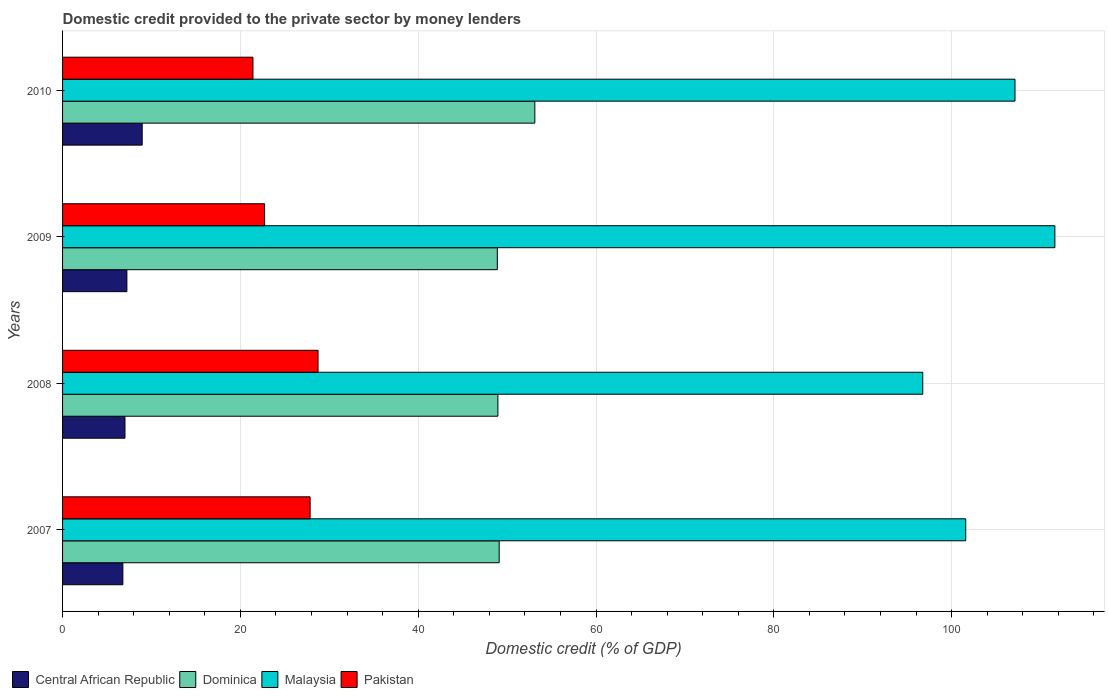How many different coloured bars are there?
Your answer should be very brief. 4. How many groups of bars are there?
Offer a terse response. 4. Are the number of bars per tick equal to the number of legend labels?
Keep it short and to the point. Yes. Are the number of bars on each tick of the Y-axis equal?
Offer a very short reply. Yes. In how many cases, is the number of bars for a given year not equal to the number of legend labels?
Make the answer very short. 0. What is the domestic credit provided to the private sector by money lenders in Pakistan in 2010?
Offer a terse response. 21.41. Across all years, what is the maximum domestic credit provided to the private sector by money lenders in Central African Republic?
Ensure brevity in your answer.  8.96. Across all years, what is the minimum domestic credit provided to the private sector by money lenders in Central African Republic?
Provide a short and direct response. 6.78. In which year was the domestic credit provided to the private sector by money lenders in Central African Republic minimum?
Offer a terse response. 2007. What is the total domestic credit provided to the private sector by money lenders in Malaysia in the graph?
Offer a terse response. 417.06. What is the difference between the domestic credit provided to the private sector by money lenders in Malaysia in 2008 and that in 2010?
Your response must be concise. -10.37. What is the difference between the domestic credit provided to the private sector by money lenders in Malaysia in 2009 and the domestic credit provided to the private sector by money lenders in Central African Republic in 2008?
Offer a very short reply. 104.59. What is the average domestic credit provided to the private sector by money lenders in Central African Republic per year?
Keep it short and to the point. 7.5. In the year 2010, what is the difference between the domestic credit provided to the private sector by money lenders in Malaysia and domestic credit provided to the private sector by money lenders in Pakistan?
Make the answer very short. 85.71. What is the ratio of the domestic credit provided to the private sector by money lenders in Pakistan in 2008 to that in 2010?
Offer a terse response. 1.34. Is the difference between the domestic credit provided to the private sector by money lenders in Malaysia in 2008 and 2010 greater than the difference between the domestic credit provided to the private sector by money lenders in Pakistan in 2008 and 2010?
Provide a succinct answer. No. What is the difference between the highest and the second highest domestic credit provided to the private sector by money lenders in Pakistan?
Your answer should be very brief. 0.89. What is the difference between the highest and the lowest domestic credit provided to the private sector by money lenders in Central African Republic?
Your answer should be very brief. 2.17. In how many years, is the domestic credit provided to the private sector by money lenders in Pakistan greater than the average domestic credit provided to the private sector by money lenders in Pakistan taken over all years?
Your response must be concise. 2. Is the sum of the domestic credit provided to the private sector by money lenders in Dominica in 2007 and 2010 greater than the maximum domestic credit provided to the private sector by money lenders in Central African Republic across all years?
Make the answer very short. Yes. Is it the case that in every year, the sum of the domestic credit provided to the private sector by money lenders in Malaysia and domestic credit provided to the private sector by money lenders in Dominica is greater than the sum of domestic credit provided to the private sector by money lenders in Central African Republic and domestic credit provided to the private sector by money lenders in Pakistan?
Provide a succinct answer. Yes. What does the 1st bar from the bottom in 2008 represents?
Make the answer very short. Central African Republic. How many bars are there?
Offer a terse response. 16. How many years are there in the graph?
Offer a very short reply. 4. What is the difference between two consecutive major ticks on the X-axis?
Ensure brevity in your answer.  20. Are the values on the major ticks of X-axis written in scientific E-notation?
Give a very brief answer. No. Does the graph contain any zero values?
Give a very brief answer. No. Does the graph contain grids?
Give a very brief answer. Yes. Where does the legend appear in the graph?
Your answer should be compact. Bottom left. How many legend labels are there?
Your response must be concise. 4. What is the title of the graph?
Provide a succinct answer. Domestic credit provided to the private sector by money lenders. What is the label or title of the X-axis?
Your response must be concise. Domestic credit (% of GDP). What is the label or title of the Y-axis?
Provide a succinct answer. Years. What is the Domestic credit (% of GDP) of Central African Republic in 2007?
Ensure brevity in your answer.  6.78. What is the Domestic credit (% of GDP) in Dominica in 2007?
Keep it short and to the point. 49.11. What is the Domestic credit (% of GDP) of Malaysia in 2007?
Your answer should be compact. 101.58. What is the Domestic credit (% of GDP) of Pakistan in 2007?
Your answer should be very brief. 27.84. What is the Domestic credit (% of GDP) of Central African Republic in 2008?
Your response must be concise. 7.02. What is the Domestic credit (% of GDP) of Dominica in 2008?
Your answer should be very brief. 48.96. What is the Domestic credit (% of GDP) of Malaysia in 2008?
Make the answer very short. 96.75. What is the Domestic credit (% of GDP) of Pakistan in 2008?
Your response must be concise. 28.73. What is the Domestic credit (% of GDP) of Central African Republic in 2009?
Your answer should be compact. 7.23. What is the Domestic credit (% of GDP) in Dominica in 2009?
Give a very brief answer. 48.9. What is the Domestic credit (% of GDP) of Malaysia in 2009?
Give a very brief answer. 111.61. What is the Domestic credit (% of GDP) of Pakistan in 2009?
Offer a very short reply. 22.72. What is the Domestic credit (% of GDP) of Central African Republic in 2010?
Ensure brevity in your answer.  8.96. What is the Domestic credit (% of GDP) of Dominica in 2010?
Provide a short and direct response. 53.12. What is the Domestic credit (% of GDP) in Malaysia in 2010?
Provide a short and direct response. 107.12. What is the Domestic credit (% of GDP) in Pakistan in 2010?
Offer a terse response. 21.41. Across all years, what is the maximum Domestic credit (% of GDP) in Central African Republic?
Provide a short and direct response. 8.96. Across all years, what is the maximum Domestic credit (% of GDP) in Dominica?
Keep it short and to the point. 53.12. Across all years, what is the maximum Domestic credit (% of GDP) of Malaysia?
Ensure brevity in your answer.  111.61. Across all years, what is the maximum Domestic credit (% of GDP) in Pakistan?
Ensure brevity in your answer.  28.73. Across all years, what is the minimum Domestic credit (% of GDP) of Central African Republic?
Provide a succinct answer. 6.78. Across all years, what is the minimum Domestic credit (% of GDP) in Dominica?
Ensure brevity in your answer.  48.9. Across all years, what is the minimum Domestic credit (% of GDP) of Malaysia?
Make the answer very short. 96.75. Across all years, what is the minimum Domestic credit (% of GDP) in Pakistan?
Ensure brevity in your answer.  21.41. What is the total Domestic credit (% of GDP) of Central African Republic in the graph?
Your answer should be compact. 29.99. What is the total Domestic credit (% of GDP) of Dominica in the graph?
Provide a succinct answer. 200.08. What is the total Domestic credit (% of GDP) of Malaysia in the graph?
Offer a terse response. 417.06. What is the total Domestic credit (% of GDP) in Pakistan in the graph?
Provide a short and direct response. 100.71. What is the difference between the Domestic credit (% of GDP) of Central African Republic in 2007 and that in 2008?
Make the answer very short. -0.24. What is the difference between the Domestic credit (% of GDP) of Dominica in 2007 and that in 2008?
Offer a very short reply. 0.15. What is the difference between the Domestic credit (% of GDP) of Malaysia in 2007 and that in 2008?
Ensure brevity in your answer.  4.83. What is the difference between the Domestic credit (% of GDP) of Pakistan in 2007 and that in 2008?
Give a very brief answer. -0.89. What is the difference between the Domestic credit (% of GDP) of Central African Republic in 2007 and that in 2009?
Provide a succinct answer. -0.45. What is the difference between the Domestic credit (% of GDP) in Dominica in 2007 and that in 2009?
Ensure brevity in your answer.  0.21. What is the difference between the Domestic credit (% of GDP) of Malaysia in 2007 and that in 2009?
Ensure brevity in your answer.  -10.03. What is the difference between the Domestic credit (% of GDP) of Pakistan in 2007 and that in 2009?
Ensure brevity in your answer.  5.12. What is the difference between the Domestic credit (% of GDP) of Central African Republic in 2007 and that in 2010?
Your answer should be very brief. -2.17. What is the difference between the Domestic credit (% of GDP) in Dominica in 2007 and that in 2010?
Your answer should be very brief. -4.01. What is the difference between the Domestic credit (% of GDP) in Malaysia in 2007 and that in 2010?
Provide a short and direct response. -5.54. What is the difference between the Domestic credit (% of GDP) in Pakistan in 2007 and that in 2010?
Offer a very short reply. 6.43. What is the difference between the Domestic credit (% of GDP) in Central African Republic in 2008 and that in 2009?
Provide a succinct answer. -0.21. What is the difference between the Domestic credit (% of GDP) of Dominica in 2008 and that in 2009?
Make the answer very short. 0.06. What is the difference between the Domestic credit (% of GDP) of Malaysia in 2008 and that in 2009?
Offer a very short reply. -14.86. What is the difference between the Domestic credit (% of GDP) of Pakistan in 2008 and that in 2009?
Offer a terse response. 6.01. What is the difference between the Domestic credit (% of GDP) in Central African Republic in 2008 and that in 2010?
Offer a terse response. -1.94. What is the difference between the Domestic credit (% of GDP) of Dominica in 2008 and that in 2010?
Offer a terse response. -4.15. What is the difference between the Domestic credit (% of GDP) in Malaysia in 2008 and that in 2010?
Keep it short and to the point. -10.37. What is the difference between the Domestic credit (% of GDP) of Pakistan in 2008 and that in 2010?
Give a very brief answer. 7.32. What is the difference between the Domestic credit (% of GDP) of Central African Republic in 2009 and that in 2010?
Your answer should be compact. -1.72. What is the difference between the Domestic credit (% of GDP) in Dominica in 2009 and that in 2010?
Your response must be concise. -4.22. What is the difference between the Domestic credit (% of GDP) of Malaysia in 2009 and that in 2010?
Provide a succinct answer. 4.48. What is the difference between the Domestic credit (% of GDP) in Pakistan in 2009 and that in 2010?
Your answer should be very brief. 1.31. What is the difference between the Domestic credit (% of GDP) of Central African Republic in 2007 and the Domestic credit (% of GDP) of Dominica in 2008?
Keep it short and to the point. -42.18. What is the difference between the Domestic credit (% of GDP) in Central African Republic in 2007 and the Domestic credit (% of GDP) in Malaysia in 2008?
Offer a very short reply. -89.97. What is the difference between the Domestic credit (% of GDP) in Central African Republic in 2007 and the Domestic credit (% of GDP) in Pakistan in 2008?
Your answer should be compact. -21.95. What is the difference between the Domestic credit (% of GDP) of Dominica in 2007 and the Domestic credit (% of GDP) of Malaysia in 2008?
Provide a succinct answer. -47.64. What is the difference between the Domestic credit (% of GDP) in Dominica in 2007 and the Domestic credit (% of GDP) in Pakistan in 2008?
Provide a succinct answer. 20.37. What is the difference between the Domestic credit (% of GDP) in Malaysia in 2007 and the Domestic credit (% of GDP) in Pakistan in 2008?
Your answer should be very brief. 72.85. What is the difference between the Domestic credit (% of GDP) of Central African Republic in 2007 and the Domestic credit (% of GDP) of Dominica in 2009?
Provide a succinct answer. -42.12. What is the difference between the Domestic credit (% of GDP) of Central African Republic in 2007 and the Domestic credit (% of GDP) of Malaysia in 2009?
Offer a terse response. -104.82. What is the difference between the Domestic credit (% of GDP) of Central African Republic in 2007 and the Domestic credit (% of GDP) of Pakistan in 2009?
Offer a very short reply. -15.94. What is the difference between the Domestic credit (% of GDP) in Dominica in 2007 and the Domestic credit (% of GDP) in Malaysia in 2009?
Provide a succinct answer. -62.5. What is the difference between the Domestic credit (% of GDP) of Dominica in 2007 and the Domestic credit (% of GDP) of Pakistan in 2009?
Provide a succinct answer. 26.39. What is the difference between the Domestic credit (% of GDP) of Malaysia in 2007 and the Domestic credit (% of GDP) of Pakistan in 2009?
Provide a succinct answer. 78.86. What is the difference between the Domestic credit (% of GDP) of Central African Republic in 2007 and the Domestic credit (% of GDP) of Dominica in 2010?
Provide a short and direct response. -46.33. What is the difference between the Domestic credit (% of GDP) in Central African Republic in 2007 and the Domestic credit (% of GDP) in Malaysia in 2010?
Offer a terse response. -100.34. What is the difference between the Domestic credit (% of GDP) of Central African Republic in 2007 and the Domestic credit (% of GDP) of Pakistan in 2010?
Offer a very short reply. -14.63. What is the difference between the Domestic credit (% of GDP) of Dominica in 2007 and the Domestic credit (% of GDP) of Malaysia in 2010?
Your answer should be compact. -58.01. What is the difference between the Domestic credit (% of GDP) in Dominica in 2007 and the Domestic credit (% of GDP) in Pakistan in 2010?
Offer a terse response. 27.7. What is the difference between the Domestic credit (% of GDP) of Malaysia in 2007 and the Domestic credit (% of GDP) of Pakistan in 2010?
Provide a short and direct response. 80.17. What is the difference between the Domestic credit (% of GDP) of Central African Republic in 2008 and the Domestic credit (% of GDP) of Dominica in 2009?
Provide a short and direct response. -41.88. What is the difference between the Domestic credit (% of GDP) of Central African Republic in 2008 and the Domestic credit (% of GDP) of Malaysia in 2009?
Give a very brief answer. -104.59. What is the difference between the Domestic credit (% of GDP) in Central African Republic in 2008 and the Domestic credit (% of GDP) in Pakistan in 2009?
Ensure brevity in your answer.  -15.7. What is the difference between the Domestic credit (% of GDP) of Dominica in 2008 and the Domestic credit (% of GDP) of Malaysia in 2009?
Offer a terse response. -62.65. What is the difference between the Domestic credit (% of GDP) of Dominica in 2008 and the Domestic credit (% of GDP) of Pakistan in 2009?
Make the answer very short. 26.24. What is the difference between the Domestic credit (% of GDP) in Malaysia in 2008 and the Domestic credit (% of GDP) in Pakistan in 2009?
Keep it short and to the point. 74.03. What is the difference between the Domestic credit (% of GDP) of Central African Republic in 2008 and the Domestic credit (% of GDP) of Dominica in 2010?
Provide a short and direct response. -46.1. What is the difference between the Domestic credit (% of GDP) in Central African Republic in 2008 and the Domestic credit (% of GDP) in Malaysia in 2010?
Give a very brief answer. -100.1. What is the difference between the Domestic credit (% of GDP) in Central African Republic in 2008 and the Domestic credit (% of GDP) in Pakistan in 2010?
Offer a terse response. -14.39. What is the difference between the Domestic credit (% of GDP) of Dominica in 2008 and the Domestic credit (% of GDP) of Malaysia in 2010?
Ensure brevity in your answer.  -58.16. What is the difference between the Domestic credit (% of GDP) in Dominica in 2008 and the Domestic credit (% of GDP) in Pakistan in 2010?
Provide a succinct answer. 27.55. What is the difference between the Domestic credit (% of GDP) in Malaysia in 2008 and the Domestic credit (% of GDP) in Pakistan in 2010?
Offer a terse response. 75.34. What is the difference between the Domestic credit (% of GDP) of Central African Republic in 2009 and the Domestic credit (% of GDP) of Dominica in 2010?
Give a very brief answer. -45.88. What is the difference between the Domestic credit (% of GDP) in Central African Republic in 2009 and the Domestic credit (% of GDP) in Malaysia in 2010?
Provide a succinct answer. -99.89. What is the difference between the Domestic credit (% of GDP) in Central African Republic in 2009 and the Domestic credit (% of GDP) in Pakistan in 2010?
Provide a short and direct response. -14.18. What is the difference between the Domestic credit (% of GDP) of Dominica in 2009 and the Domestic credit (% of GDP) of Malaysia in 2010?
Make the answer very short. -58.22. What is the difference between the Domestic credit (% of GDP) of Dominica in 2009 and the Domestic credit (% of GDP) of Pakistan in 2010?
Give a very brief answer. 27.49. What is the difference between the Domestic credit (% of GDP) in Malaysia in 2009 and the Domestic credit (% of GDP) in Pakistan in 2010?
Offer a terse response. 90.19. What is the average Domestic credit (% of GDP) in Central African Republic per year?
Your answer should be compact. 7.5. What is the average Domestic credit (% of GDP) of Dominica per year?
Give a very brief answer. 50.02. What is the average Domestic credit (% of GDP) in Malaysia per year?
Your answer should be compact. 104.26. What is the average Domestic credit (% of GDP) of Pakistan per year?
Your response must be concise. 25.18. In the year 2007, what is the difference between the Domestic credit (% of GDP) of Central African Republic and Domestic credit (% of GDP) of Dominica?
Give a very brief answer. -42.33. In the year 2007, what is the difference between the Domestic credit (% of GDP) in Central African Republic and Domestic credit (% of GDP) in Malaysia?
Your answer should be compact. -94.8. In the year 2007, what is the difference between the Domestic credit (% of GDP) of Central African Republic and Domestic credit (% of GDP) of Pakistan?
Make the answer very short. -21.06. In the year 2007, what is the difference between the Domestic credit (% of GDP) in Dominica and Domestic credit (% of GDP) in Malaysia?
Offer a very short reply. -52.47. In the year 2007, what is the difference between the Domestic credit (% of GDP) of Dominica and Domestic credit (% of GDP) of Pakistan?
Your answer should be very brief. 21.27. In the year 2007, what is the difference between the Domestic credit (% of GDP) in Malaysia and Domestic credit (% of GDP) in Pakistan?
Ensure brevity in your answer.  73.74. In the year 2008, what is the difference between the Domestic credit (% of GDP) in Central African Republic and Domestic credit (% of GDP) in Dominica?
Offer a terse response. -41.94. In the year 2008, what is the difference between the Domestic credit (% of GDP) of Central African Republic and Domestic credit (% of GDP) of Malaysia?
Ensure brevity in your answer.  -89.73. In the year 2008, what is the difference between the Domestic credit (% of GDP) of Central African Republic and Domestic credit (% of GDP) of Pakistan?
Provide a succinct answer. -21.71. In the year 2008, what is the difference between the Domestic credit (% of GDP) in Dominica and Domestic credit (% of GDP) in Malaysia?
Offer a terse response. -47.79. In the year 2008, what is the difference between the Domestic credit (% of GDP) of Dominica and Domestic credit (% of GDP) of Pakistan?
Offer a terse response. 20.23. In the year 2008, what is the difference between the Domestic credit (% of GDP) in Malaysia and Domestic credit (% of GDP) in Pakistan?
Ensure brevity in your answer.  68.01. In the year 2009, what is the difference between the Domestic credit (% of GDP) in Central African Republic and Domestic credit (% of GDP) in Dominica?
Your response must be concise. -41.66. In the year 2009, what is the difference between the Domestic credit (% of GDP) of Central African Republic and Domestic credit (% of GDP) of Malaysia?
Your answer should be very brief. -104.37. In the year 2009, what is the difference between the Domestic credit (% of GDP) of Central African Republic and Domestic credit (% of GDP) of Pakistan?
Ensure brevity in your answer.  -15.49. In the year 2009, what is the difference between the Domestic credit (% of GDP) in Dominica and Domestic credit (% of GDP) in Malaysia?
Offer a very short reply. -62.71. In the year 2009, what is the difference between the Domestic credit (% of GDP) of Dominica and Domestic credit (% of GDP) of Pakistan?
Your answer should be very brief. 26.18. In the year 2009, what is the difference between the Domestic credit (% of GDP) of Malaysia and Domestic credit (% of GDP) of Pakistan?
Offer a terse response. 88.88. In the year 2010, what is the difference between the Domestic credit (% of GDP) in Central African Republic and Domestic credit (% of GDP) in Dominica?
Offer a terse response. -44.16. In the year 2010, what is the difference between the Domestic credit (% of GDP) in Central African Republic and Domestic credit (% of GDP) in Malaysia?
Give a very brief answer. -98.17. In the year 2010, what is the difference between the Domestic credit (% of GDP) in Central African Republic and Domestic credit (% of GDP) in Pakistan?
Ensure brevity in your answer.  -12.46. In the year 2010, what is the difference between the Domestic credit (% of GDP) in Dominica and Domestic credit (% of GDP) in Malaysia?
Ensure brevity in your answer.  -54.01. In the year 2010, what is the difference between the Domestic credit (% of GDP) of Dominica and Domestic credit (% of GDP) of Pakistan?
Offer a very short reply. 31.7. In the year 2010, what is the difference between the Domestic credit (% of GDP) of Malaysia and Domestic credit (% of GDP) of Pakistan?
Make the answer very short. 85.71. What is the ratio of the Domestic credit (% of GDP) in Central African Republic in 2007 to that in 2008?
Keep it short and to the point. 0.97. What is the ratio of the Domestic credit (% of GDP) of Malaysia in 2007 to that in 2008?
Make the answer very short. 1.05. What is the ratio of the Domestic credit (% of GDP) in Central African Republic in 2007 to that in 2009?
Offer a terse response. 0.94. What is the ratio of the Domestic credit (% of GDP) in Dominica in 2007 to that in 2009?
Your answer should be compact. 1. What is the ratio of the Domestic credit (% of GDP) of Malaysia in 2007 to that in 2009?
Provide a short and direct response. 0.91. What is the ratio of the Domestic credit (% of GDP) of Pakistan in 2007 to that in 2009?
Your response must be concise. 1.23. What is the ratio of the Domestic credit (% of GDP) of Central African Republic in 2007 to that in 2010?
Offer a very short reply. 0.76. What is the ratio of the Domestic credit (% of GDP) of Dominica in 2007 to that in 2010?
Give a very brief answer. 0.92. What is the ratio of the Domestic credit (% of GDP) in Malaysia in 2007 to that in 2010?
Offer a terse response. 0.95. What is the ratio of the Domestic credit (% of GDP) of Pakistan in 2007 to that in 2010?
Your answer should be very brief. 1.3. What is the ratio of the Domestic credit (% of GDP) of Central African Republic in 2008 to that in 2009?
Your response must be concise. 0.97. What is the ratio of the Domestic credit (% of GDP) of Malaysia in 2008 to that in 2009?
Give a very brief answer. 0.87. What is the ratio of the Domestic credit (% of GDP) in Pakistan in 2008 to that in 2009?
Offer a very short reply. 1.26. What is the ratio of the Domestic credit (% of GDP) in Central African Republic in 2008 to that in 2010?
Keep it short and to the point. 0.78. What is the ratio of the Domestic credit (% of GDP) of Dominica in 2008 to that in 2010?
Offer a very short reply. 0.92. What is the ratio of the Domestic credit (% of GDP) of Malaysia in 2008 to that in 2010?
Your answer should be compact. 0.9. What is the ratio of the Domestic credit (% of GDP) of Pakistan in 2008 to that in 2010?
Ensure brevity in your answer.  1.34. What is the ratio of the Domestic credit (% of GDP) in Central African Republic in 2009 to that in 2010?
Provide a succinct answer. 0.81. What is the ratio of the Domestic credit (% of GDP) of Dominica in 2009 to that in 2010?
Give a very brief answer. 0.92. What is the ratio of the Domestic credit (% of GDP) of Malaysia in 2009 to that in 2010?
Give a very brief answer. 1.04. What is the ratio of the Domestic credit (% of GDP) in Pakistan in 2009 to that in 2010?
Ensure brevity in your answer.  1.06. What is the difference between the highest and the second highest Domestic credit (% of GDP) of Central African Republic?
Your answer should be compact. 1.72. What is the difference between the highest and the second highest Domestic credit (% of GDP) of Dominica?
Your answer should be very brief. 4.01. What is the difference between the highest and the second highest Domestic credit (% of GDP) in Malaysia?
Provide a succinct answer. 4.48. What is the difference between the highest and the second highest Domestic credit (% of GDP) of Pakistan?
Your answer should be very brief. 0.89. What is the difference between the highest and the lowest Domestic credit (% of GDP) of Central African Republic?
Keep it short and to the point. 2.17. What is the difference between the highest and the lowest Domestic credit (% of GDP) of Dominica?
Give a very brief answer. 4.22. What is the difference between the highest and the lowest Domestic credit (% of GDP) of Malaysia?
Provide a short and direct response. 14.86. What is the difference between the highest and the lowest Domestic credit (% of GDP) in Pakistan?
Offer a terse response. 7.32. 